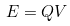Convert formula to latex. <formula><loc_0><loc_0><loc_500><loc_500>E = Q V</formula> 